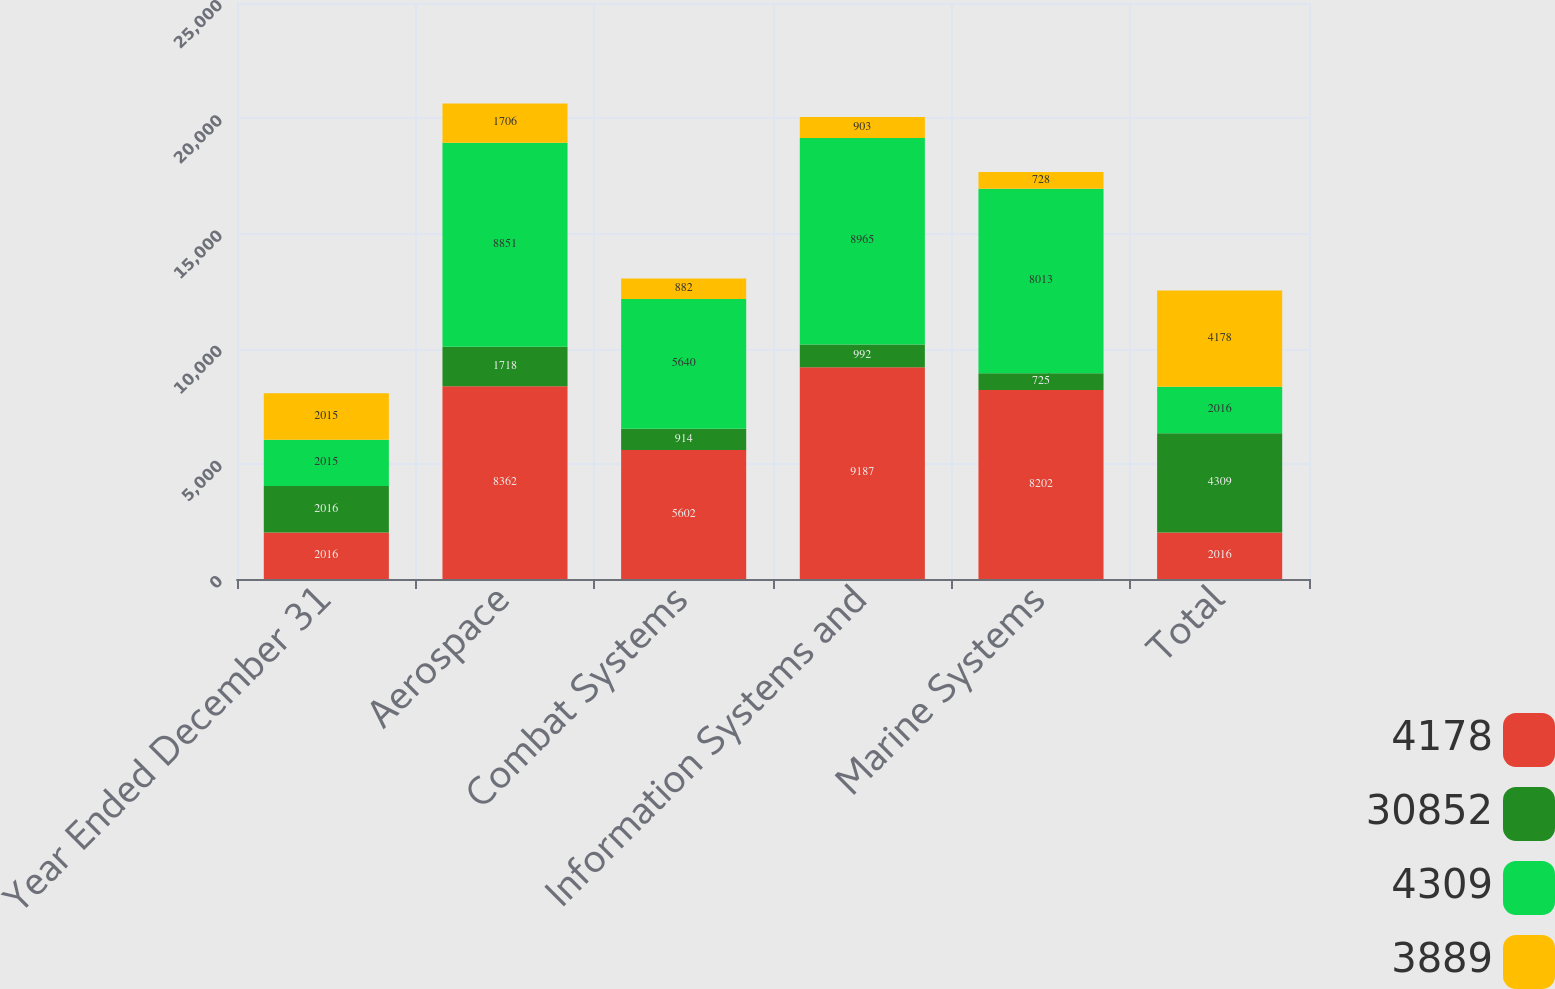<chart> <loc_0><loc_0><loc_500><loc_500><stacked_bar_chart><ecel><fcel>Year Ended December 31<fcel>Aerospace<fcel>Combat Systems<fcel>Information Systems and<fcel>Marine Systems<fcel>Total<nl><fcel>4178<fcel>2016<fcel>8362<fcel>5602<fcel>9187<fcel>8202<fcel>2016<nl><fcel>30852<fcel>2016<fcel>1718<fcel>914<fcel>992<fcel>725<fcel>4309<nl><fcel>4309<fcel>2015<fcel>8851<fcel>5640<fcel>8965<fcel>8013<fcel>2016<nl><fcel>3889<fcel>2015<fcel>1706<fcel>882<fcel>903<fcel>728<fcel>4178<nl></chart> 